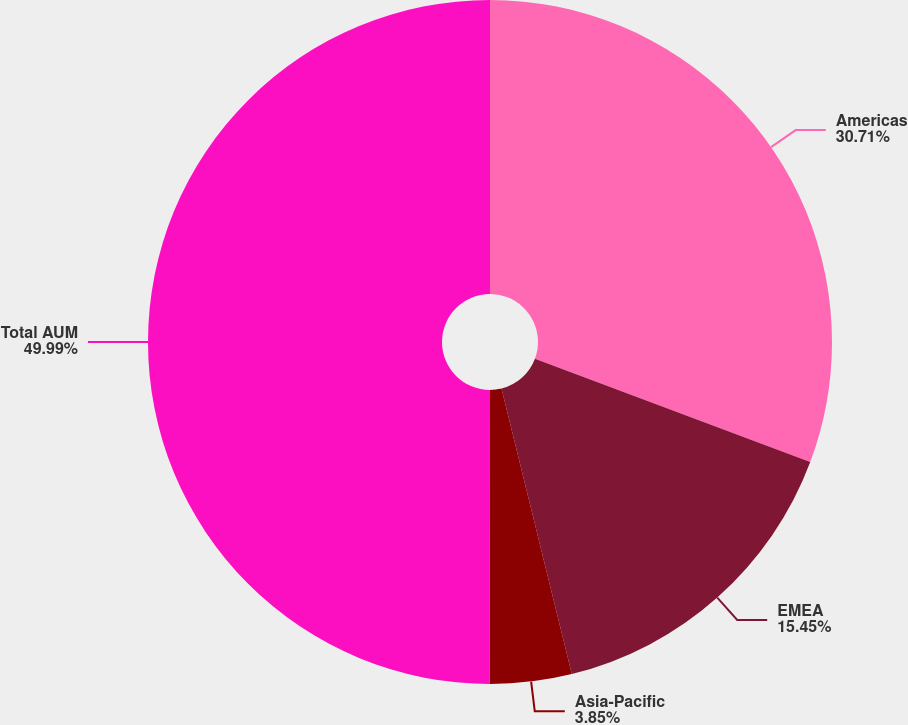Convert chart to OTSL. <chart><loc_0><loc_0><loc_500><loc_500><pie_chart><fcel>Americas<fcel>EMEA<fcel>Asia-Pacific<fcel>Total AUM<nl><fcel>30.71%<fcel>15.45%<fcel>3.85%<fcel>50.0%<nl></chart> 